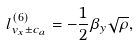Convert formula to latex. <formula><loc_0><loc_0><loc_500><loc_500>l _ { v _ { x } \pm c _ { a } } ^ { ( 6 ) } = - \frac { 1 } { 2 } \beta _ { y } \sqrt { \rho } ,</formula> 